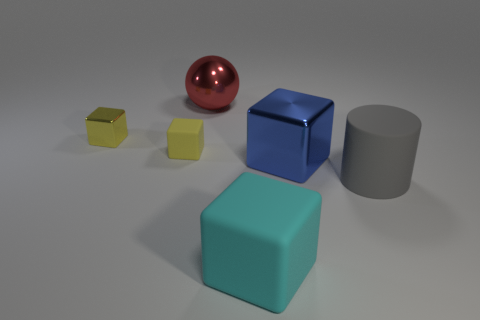Is the number of metal objects to the left of the cyan rubber object greater than the number of small yellow metallic blocks?
Your answer should be very brief. Yes. How many other things are the same shape as the big cyan rubber thing?
Keep it short and to the point. 3. There is a object that is behind the blue metal cube and in front of the small yellow shiny block; what material is it?
Keep it short and to the point. Rubber. How many things are large yellow metallic cylinders or big cyan objects?
Give a very brief answer. 1. Is the number of large cyan objects greater than the number of yellow objects?
Make the answer very short. No. How big is the rubber cube behind the cylinder that is right of the small shiny block?
Your answer should be compact. Small. There is a small rubber thing that is the same shape as the big cyan rubber thing; what is its color?
Offer a terse response. Yellow. What size is the blue block?
Your response must be concise. Large. How many balls are red shiny objects or yellow metallic objects?
Make the answer very short. 1. There is a blue thing that is the same shape as the cyan thing; what is its size?
Make the answer very short. Large. 